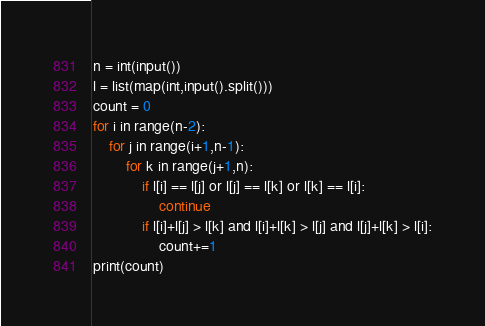<code> <loc_0><loc_0><loc_500><loc_500><_Python_>n = int(input())
l = list(map(int,input().split()))
count = 0
for i in range(n-2):
    for j in range(i+1,n-1):
        for k in range(j+1,n):
            if l[i] == l[j] or l[j] == l[k] or l[k] == l[i]:
                continue
            if l[i]+l[j] > l[k] and l[i]+l[k] > l[j] and l[j]+l[k] > l[i]:
                count+=1
print(count)</code> 